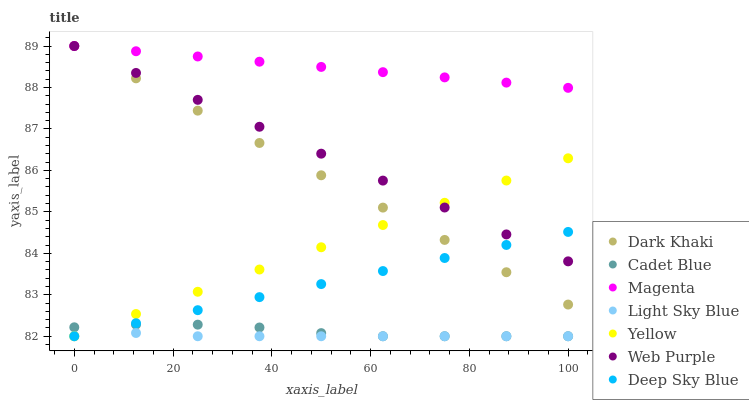Does Light Sky Blue have the minimum area under the curve?
Answer yes or no. Yes. Does Magenta have the maximum area under the curve?
Answer yes or no. Yes. Does Yellow have the minimum area under the curve?
Answer yes or no. No. Does Yellow have the maximum area under the curve?
Answer yes or no. No. Is Dark Khaki the smoothest?
Answer yes or no. Yes. Is Cadet Blue the roughest?
Answer yes or no. Yes. Is Yellow the smoothest?
Answer yes or no. No. Is Yellow the roughest?
Answer yes or no. No. Does Cadet Blue have the lowest value?
Answer yes or no. Yes. Does Dark Khaki have the lowest value?
Answer yes or no. No. Does Magenta have the highest value?
Answer yes or no. Yes. Does Yellow have the highest value?
Answer yes or no. No. Is Yellow less than Magenta?
Answer yes or no. Yes. Is Web Purple greater than Light Sky Blue?
Answer yes or no. Yes. Does Web Purple intersect Yellow?
Answer yes or no. Yes. Is Web Purple less than Yellow?
Answer yes or no. No. Is Web Purple greater than Yellow?
Answer yes or no. No. Does Yellow intersect Magenta?
Answer yes or no. No. 